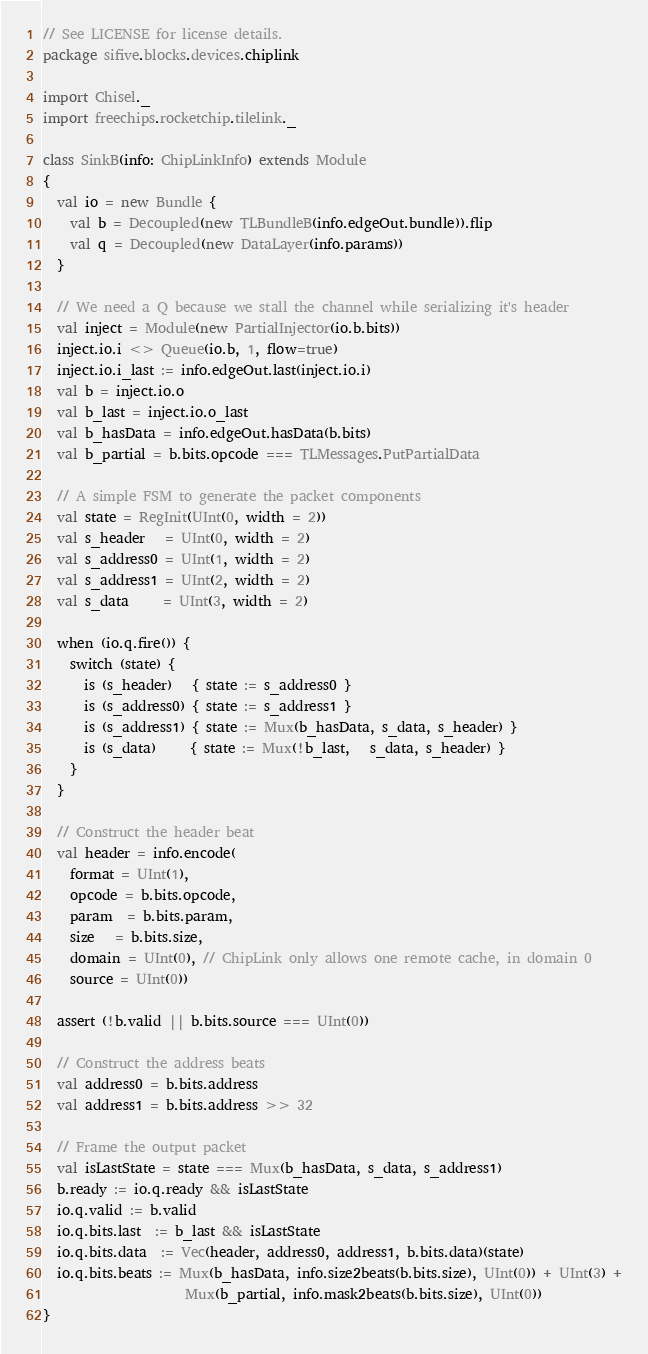Convert code to text. <code><loc_0><loc_0><loc_500><loc_500><_Scala_>// See LICENSE for license details.
package sifive.blocks.devices.chiplink

import Chisel._
import freechips.rocketchip.tilelink._

class SinkB(info: ChipLinkInfo) extends Module
{
  val io = new Bundle {
    val b = Decoupled(new TLBundleB(info.edgeOut.bundle)).flip
    val q = Decoupled(new DataLayer(info.params))
  }

  // We need a Q because we stall the channel while serializing it's header
  val inject = Module(new PartialInjector(io.b.bits))
  inject.io.i <> Queue(io.b, 1, flow=true)
  inject.io.i_last := info.edgeOut.last(inject.io.i)
  val b = inject.io.o
  val b_last = inject.io.o_last
  val b_hasData = info.edgeOut.hasData(b.bits)
  val b_partial = b.bits.opcode === TLMessages.PutPartialData

  // A simple FSM to generate the packet components
  val state = RegInit(UInt(0, width = 2))
  val s_header   = UInt(0, width = 2)
  val s_address0 = UInt(1, width = 2)
  val s_address1 = UInt(2, width = 2)
  val s_data     = UInt(3, width = 2)

  when (io.q.fire()) {
    switch (state) {
      is (s_header)   { state := s_address0 }
      is (s_address0) { state := s_address1 }
      is (s_address1) { state := Mux(b_hasData, s_data, s_header) }
      is (s_data)     { state := Mux(!b_last,   s_data, s_header) }
    }
  }

  // Construct the header beat
  val header = info.encode(
    format = UInt(1),
    opcode = b.bits.opcode,
    param  = b.bits.param,
    size   = b.bits.size,
    domain = UInt(0), // ChipLink only allows one remote cache, in domain 0
    source = UInt(0))

  assert (!b.valid || b.bits.source === UInt(0))

  // Construct the address beats
  val address0 = b.bits.address
  val address1 = b.bits.address >> 32

  // Frame the output packet
  val isLastState = state === Mux(b_hasData, s_data, s_address1)
  b.ready := io.q.ready && isLastState
  io.q.valid := b.valid
  io.q.bits.last  := b_last && isLastState
  io.q.bits.data  := Vec(header, address0, address1, b.bits.data)(state)
  io.q.bits.beats := Mux(b_hasData, info.size2beats(b.bits.size), UInt(0)) + UInt(3) +
                     Mux(b_partial, info.mask2beats(b.bits.size), UInt(0))
}
</code> 